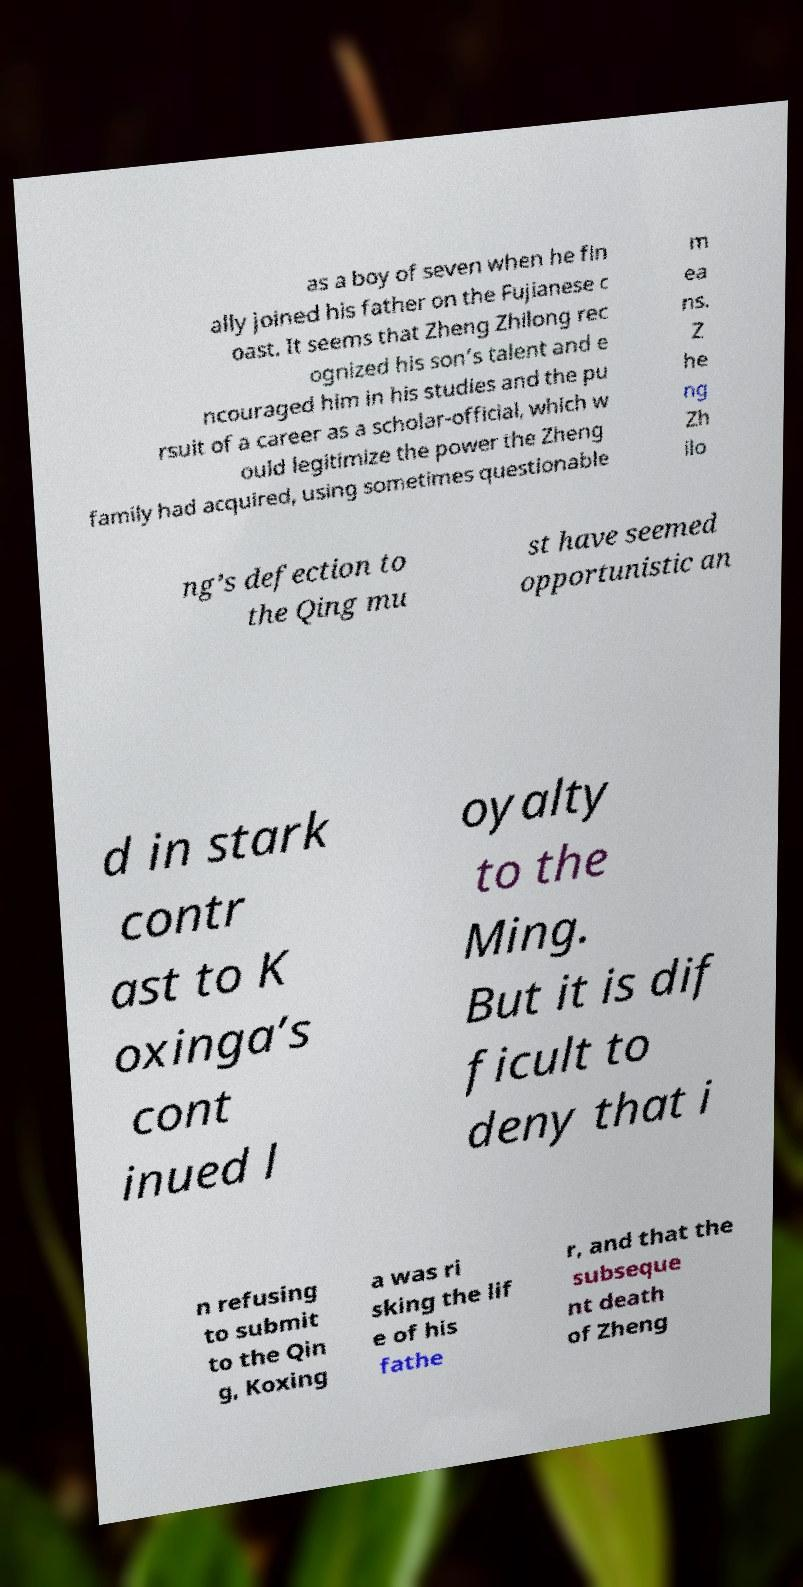Please read and relay the text visible in this image. What does it say? as a boy of seven when he fin ally joined his father on the Fujianese c oast. It seems that Zheng Zhilong rec ognized his son’s talent and e ncouraged him in his studies and the pu rsuit of a career as a scholar-official, which w ould legitimize the power the Zheng family had acquired, using sometimes questionable m ea ns. Z he ng Zh ilo ng’s defection to the Qing mu st have seemed opportunistic an d in stark contr ast to K oxinga’s cont inued l oyalty to the Ming. But it is dif ficult to deny that i n refusing to submit to the Qin g, Koxing a was ri sking the lif e of his fathe r, and that the subseque nt death of Zheng 